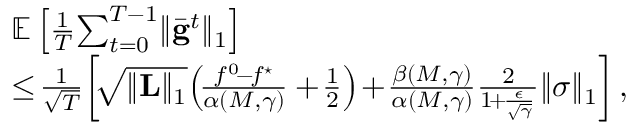<formula> <loc_0><loc_0><loc_500><loc_500>\begin{array} { r l } & { \mathbb { E } \left [ \frac { 1 } { T } \, \sum _ { t = 0 } ^ { T - 1 } \| \bar { g } ^ { t } \| _ { 1 } \right ] } \\ & { \leq \, \frac { 1 } { \sqrt { T } } \, \left [ \, \sqrt { \| L \| _ { 1 } } \, \left ( \, \frac { f ^ { 0 } \, - \, f ^ { ^ { * } } } { \alpha ( M , \gamma ) } + \, \frac { 1 } { 2 } \right ) \, + \, \frac { \beta ( M , \gamma ) } { \alpha ( M , \gamma ) } \frac { 2 } { 1 \, + \, \frac { \epsilon } { \sqrt { \gamma } } } \| \sigma \| _ { 1 } \right ] , } \end{array}</formula> 